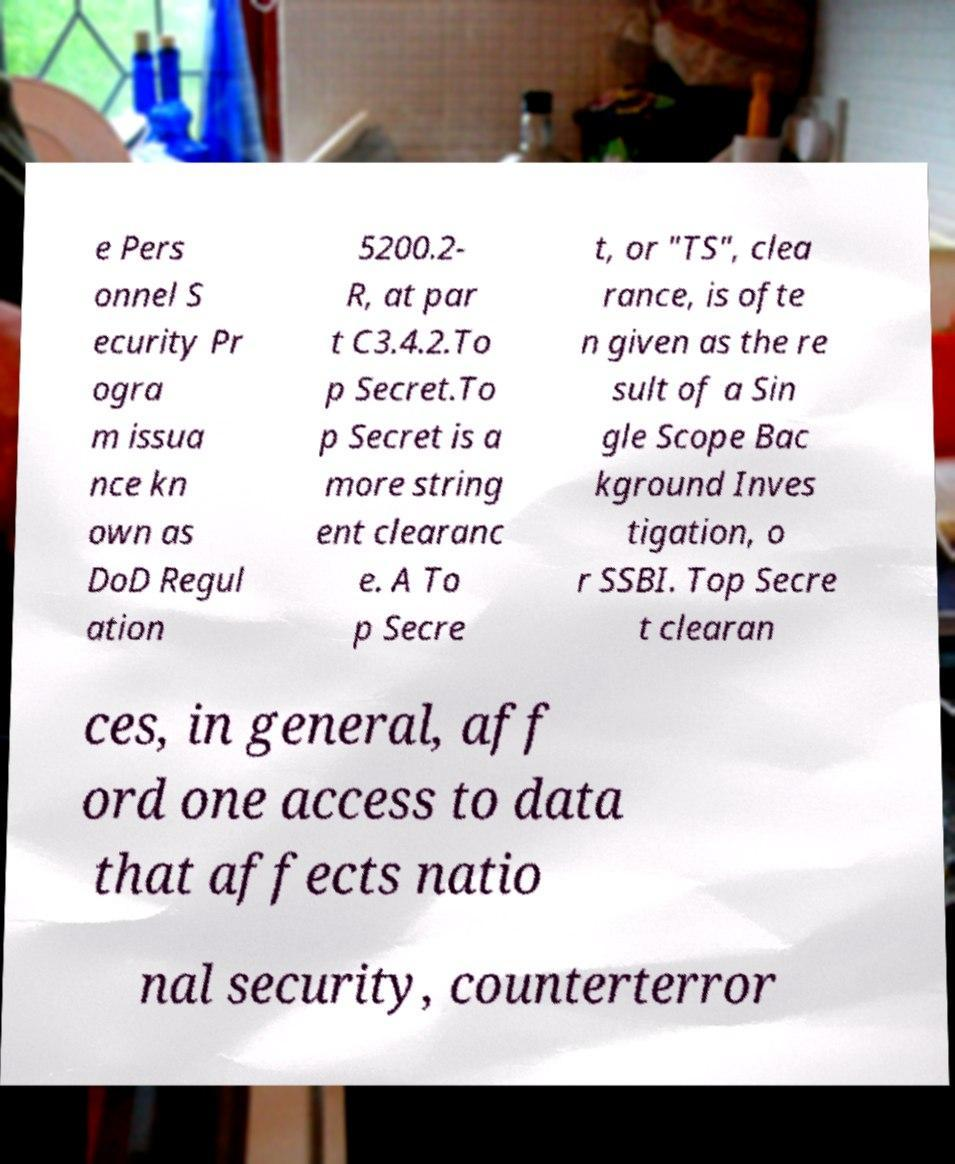Please identify and transcribe the text found in this image. e Pers onnel S ecurity Pr ogra m issua nce kn own as DoD Regul ation 5200.2- R, at par t C3.4.2.To p Secret.To p Secret is a more string ent clearanc e. A To p Secre t, or "TS", clea rance, is ofte n given as the re sult of a Sin gle Scope Bac kground Inves tigation, o r SSBI. Top Secre t clearan ces, in general, aff ord one access to data that affects natio nal security, counterterror 